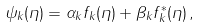Convert formula to latex. <formula><loc_0><loc_0><loc_500><loc_500>\psi _ { k } ( \eta ) = \alpha _ { k } f _ { k } ( \eta ) + \beta _ { k } f _ { k } ^ { * } ( \eta ) \, ,</formula> 